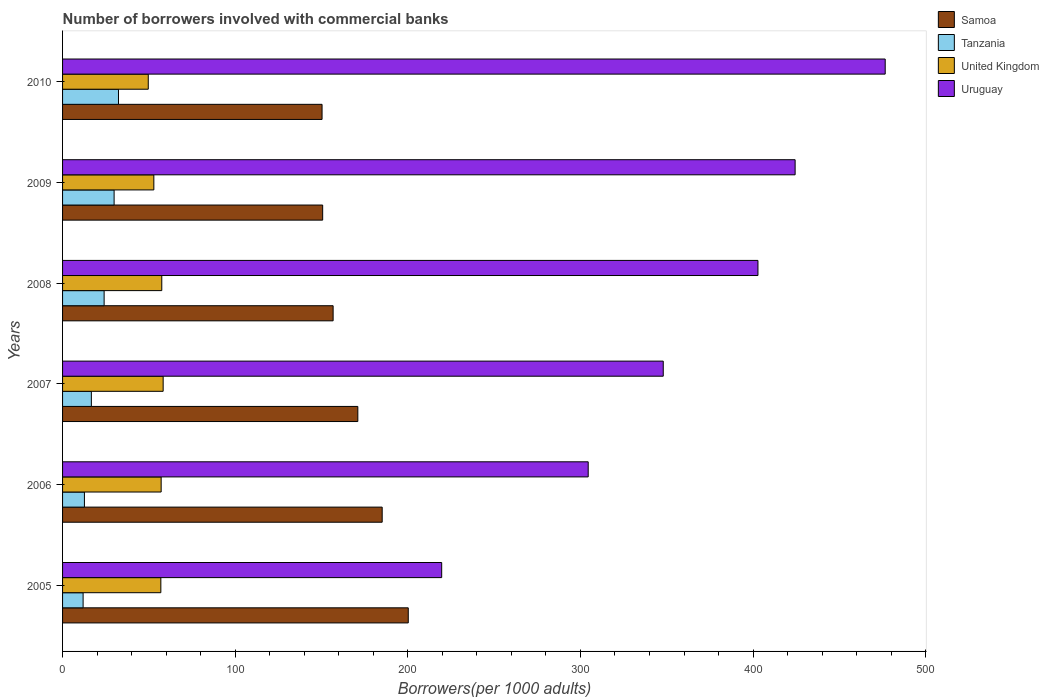How many different coloured bars are there?
Make the answer very short. 4. Are the number of bars per tick equal to the number of legend labels?
Give a very brief answer. Yes. How many bars are there on the 1st tick from the top?
Your answer should be compact. 4. How many bars are there on the 6th tick from the bottom?
Your answer should be compact. 4. In how many cases, is the number of bars for a given year not equal to the number of legend labels?
Make the answer very short. 0. What is the number of borrowers involved with commercial banks in United Kingdom in 2005?
Make the answer very short. 56.93. Across all years, what is the maximum number of borrowers involved with commercial banks in Samoa?
Ensure brevity in your answer.  200.26. Across all years, what is the minimum number of borrowers involved with commercial banks in United Kingdom?
Provide a succinct answer. 49.65. In which year was the number of borrowers involved with commercial banks in Samoa minimum?
Your answer should be very brief. 2010. What is the total number of borrowers involved with commercial banks in United Kingdom in the graph?
Your response must be concise. 332.32. What is the difference between the number of borrowers involved with commercial banks in Uruguay in 2005 and that in 2010?
Your answer should be very brief. -256.93. What is the difference between the number of borrowers involved with commercial banks in Tanzania in 2005 and the number of borrowers involved with commercial banks in United Kingdom in 2008?
Give a very brief answer. -45.57. What is the average number of borrowers involved with commercial banks in Samoa per year?
Provide a succinct answer. 169.03. In the year 2008, what is the difference between the number of borrowers involved with commercial banks in United Kingdom and number of borrowers involved with commercial banks in Uruguay?
Make the answer very short. -345.36. In how many years, is the number of borrowers involved with commercial banks in Tanzania greater than 360 ?
Provide a succinct answer. 0. What is the ratio of the number of borrowers involved with commercial banks in Uruguay in 2007 to that in 2008?
Keep it short and to the point. 0.86. Is the number of borrowers involved with commercial banks in Uruguay in 2006 less than that in 2010?
Your answer should be very brief. Yes. Is the difference between the number of borrowers involved with commercial banks in United Kingdom in 2006 and 2010 greater than the difference between the number of borrowers involved with commercial banks in Uruguay in 2006 and 2010?
Give a very brief answer. Yes. What is the difference between the highest and the second highest number of borrowers involved with commercial banks in Tanzania?
Offer a very short reply. 2.54. What is the difference between the highest and the lowest number of borrowers involved with commercial banks in United Kingdom?
Make the answer very short. 8.62. Is it the case that in every year, the sum of the number of borrowers involved with commercial banks in Tanzania and number of borrowers involved with commercial banks in Samoa is greater than the sum of number of borrowers involved with commercial banks in Uruguay and number of borrowers involved with commercial banks in United Kingdom?
Your answer should be very brief. No. What does the 3rd bar from the top in 2008 represents?
Give a very brief answer. Tanzania. What does the 4th bar from the bottom in 2010 represents?
Offer a very short reply. Uruguay. Is it the case that in every year, the sum of the number of borrowers involved with commercial banks in Uruguay and number of borrowers involved with commercial banks in United Kingdom is greater than the number of borrowers involved with commercial banks in Tanzania?
Offer a terse response. Yes. How many years are there in the graph?
Offer a terse response. 6. Does the graph contain any zero values?
Make the answer very short. No. Does the graph contain grids?
Ensure brevity in your answer.  No. Where does the legend appear in the graph?
Your answer should be compact. Top right. How many legend labels are there?
Give a very brief answer. 4. How are the legend labels stacked?
Ensure brevity in your answer.  Vertical. What is the title of the graph?
Provide a short and direct response. Number of borrowers involved with commercial banks. What is the label or title of the X-axis?
Offer a very short reply. Borrowers(per 1000 adults). What is the label or title of the Y-axis?
Your answer should be very brief. Years. What is the Borrowers(per 1000 adults) of Samoa in 2005?
Provide a succinct answer. 200.26. What is the Borrowers(per 1000 adults) of Tanzania in 2005?
Your answer should be compact. 11.9. What is the Borrowers(per 1000 adults) in United Kingdom in 2005?
Give a very brief answer. 56.93. What is the Borrowers(per 1000 adults) in Uruguay in 2005?
Make the answer very short. 219.62. What is the Borrowers(per 1000 adults) of Samoa in 2006?
Ensure brevity in your answer.  185.16. What is the Borrowers(per 1000 adults) in Tanzania in 2006?
Make the answer very short. 12.66. What is the Borrowers(per 1000 adults) of United Kingdom in 2006?
Your answer should be very brief. 57.12. What is the Borrowers(per 1000 adults) in Uruguay in 2006?
Your answer should be very brief. 304.5. What is the Borrowers(per 1000 adults) in Samoa in 2007?
Provide a succinct answer. 171.04. What is the Borrowers(per 1000 adults) of Tanzania in 2007?
Offer a very short reply. 16.68. What is the Borrowers(per 1000 adults) of United Kingdom in 2007?
Give a very brief answer. 58.27. What is the Borrowers(per 1000 adults) of Uruguay in 2007?
Ensure brevity in your answer.  347.97. What is the Borrowers(per 1000 adults) in Samoa in 2008?
Your answer should be compact. 156.73. What is the Borrowers(per 1000 adults) in Tanzania in 2008?
Your response must be concise. 24.08. What is the Borrowers(per 1000 adults) of United Kingdom in 2008?
Your answer should be compact. 57.47. What is the Borrowers(per 1000 adults) of Uruguay in 2008?
Provide a succinct answer. 402.84. What is the Borrowers(per 1000 adults) of Samoa in 2009?
Provide a succinct answer. 150.68. What is the Borrowers(per 1000 adults) of Tanzania in 2009?
Provide a short and direct response. 29.86. What is the Borrowers(per 1000 adults) of United Kingdom in 2009?
Your answer should be compact. 52.88. What is the Borrowers(per 1000 adults) in Uruguay in 2009?
Keep it short and to the point. 424.36. What is the Borrowers(per 1000 adults) in Samoa in 2010?
Your answer should be compact. 150.32. What is the Borrowers(per 1000 adults) of Tanzania in 2010?
Offer a terse response. 32.39. What is the Borrowers(per 1000 adults) of United Kingdom in 2010?
Offer a terse response. 49.65. What is the Borrowers(per 1000 adults) in Uruguay in 2010?
Provide a short and direct response. 476.55. Across all years, what is the maximum Borrowers(per 1000 adults) of Samoa?
Your response must be concise. 200.26. Across all years, what is the maximum Borrowers(per 1000 adults) in Tanzania?
Offer a terse response. 32.39. Across all years, what is the maximum Borrowers(per 1000 adults) in United Kingdom?
Make the answer very short. 58.27. Across all years, what is the maximum Borrowers(per 1000 adults) in Uruguay?
Your response must be concise. 476.55. Across all years, what is the minimum Borrowers(per 1000 adults) of Samoa?
Your response must be concise. 150.32. Across all years, what is the minimum Borrowers(per 1000 adults) of Tanzania?
Provide a succinct answer. 11.9. Across all years, what is the minimum Borrowers(per 1000 adults) of United Kingdom?
Provide a short and direct response. 49.65. Across all years, what is the minimum Borrowers(per 1000 adults) of Uruguay?
Provide a succinct answer. 219.62. What is the total Borrowers(per 1000 adults) of Samoa in the graph?
Keep it short and to the point. 1014.19. What is the total Borrowers(per 1000 adults) of Tanzania in the graph?
Keep it short and to the point. 127.56. What is the total Borrowers(per 1000 adults) in United Kingdom in the graph?
Your response must be concise. 332.32. What is the total Borrowers(per 1000 adults) in Uruguay in the graph?
Keep it short and to the point. 2175.85. What is the difference between the Borrowers(per 1000 adults) of Samoa in 2005 and that in 2006?
Make the answer very short. 15.11. What is the difference between the Borrowers(per 1000 adults) of Tanzania in 2005 and that in 2006?
Ensure brevity in your answer.  -0.76. What is the difference between the Borrowers(per 1000 adults) of United Kingdom in 2005 and that in 2006?
Offer a terse response. -0.19. What is the difference between the Borrowers(per 1000 adults) in Uruguay in 2005 and that in 2006?
Provide a short and direct response. -84.88. What is the difference between the Borrowers(per 1000 adults) in Samoa in 2005 and that in 2007?
Keep it short and to the point. 29.22. What is the difference between the Borrowers(per 1000 adults) in Tanzania in 2005 and that in 2007?
Offer a terse response. -4.78. What is the difference between the Borrowers(per 1000 adults) in United Kingdom in 2005 and that in 2007?
Provide a short and direct response. -1.34. What is the difference between the Borrowers(per 1000 adults) of Uruguay in 2005 and that in 2007?
Make the answer very short. -128.35. What is the difference between the Borrowers(per 1000 adults) of Samoa in 2005 and that in 2008?
Give a very brief answer. 43.53. What is the difference between the Borrowers(per 1000 adults) of Tanzania in 2005 and that in 2008?
Offer a terse response. -12.17. What is the difference between the Borrowers(per 1000 adults) in United Kingdom in 2005 and that in 2008?
Your response must be concise. -0.54. What is the difference between the Borrowers(per 1000 adults) in Uruguay in 2005 and that in 2008?
Ensure brevity in your answer.  -183.21. What is the difference between the Borrowers(per 1000 adults) of Samoa in 2005 and that in 2009?
Give a very brief answer. 49.59. What is the difference between the Borrowers(per 1000 adults) in Tanzania in 2005 and that in 2009?
Keep it short and to the point. -17.95. What is the difference between the Borrowers(per 1000 adults) in United Kingdom in 2005 and that in 2009?
Your answer should be compact. 4.05. What is the difference between the Borrowers(per 1000 adults) in Uruguay in 2005 and that in 2009?
Provide a short and direct response. -204.74. What is the difference between the Borrowers(per 1000 adults) of Samoa in 2005 and that in 2010?
Your answer should be compact. 49.94. What is the difference between the Borrowers(per 1000 adults) of Tanzania in 2005 and that in 2010?
Give a very brief answer. -20.49. What is the difference between the Borrowers(per 1000 adults) in United Kingdom in 2005 and that in 2010?
Offer a terse response. 7.28. What is the difference between the Borrowers(per 1000 adults) of Uruguay in 2005 and that in 2010?
Give a very brief answer. -256.93. What is the difference between the Borrowers(per 1000 adults) of Samoa in 2006 and that in 2007?
Your answer should be very brief. 14.11. What is the difference between the Borrowers(per 1000 adults) in Tanzania in 2006 and that in 2007?
Your answer should be very brief. -4.02. What is the difference between the Borrowers(per 1000 adults) in United Kingdom in 2006 and that in 2007?
Your answer should be compact. -1.15. What is the difference between the Borrowers(per 1000 adults) in Uruguay in 2006 and that in 2007?
Make the answer very short. -43.47. What is the difference between the Borrowers(per 1000 adults) in Samoa in 2006 and that in 2008?
Give a very brief answer. 28.42. What is the difference between the Borrowers(per 1000 adults) in Tanzania in 2006 and that in 2008?
Your response must be concise. -11.42. What is the difference between the Borrowers(per 1000 adults) in United Kingdom in 2006 and that in 2008?
Offer a terse response. -0.36. What is the difference between the Borrowers(per 1000 adults) in Uruguay in 2006 and that in 2008?
Your answer should be compact. -98.33. What is the difference between the Borrowers(per 1000 adults) in Samoa in 2006 and that in 2009?
Ensure brevity in your answer.  34.48. What is the difference between the Borrowers(per 1000 adults) of Tanzania in 2006 and that in 2009?
Your answer should be very brief. -17.2. What is the difference between the Borrowers(per 1000 adults) of United Kingdom in 2006 and that in 2009?
Make the answer very short. 4.24. What is the difference between the Borrowers(per 1000 adults) in Uruguay in 2006 and that in 2009?
Your answer should be very brief. -119.86. What is the difference between the Borrowers(per 1000 adults) in Samoa in 2006 and that in 2010?
Offer a terse response. 34.83. What is the difference between the Borrowers(per 1000 adults) of Tanzania in 2006 and that in 2010?
Provide a short and direct response. -19.73. What is the difference between the Borrowers(per 1000 adults) in United Kingdom in 2006 and that in 2010?
Your answer should be very brief. 7.47. What is the difference between the Borrowers(per 1000 adults) in Uruguay in 2006 and that in 2010?
Give a very brief answer. -172.05. What is the difference between the Borrowers(per 1000 adults) in Samoa in 2007 and that in 2008?
Ensure brevity in your answer.  14.31. What is the difference between the Borrowers(per 1000 adults) of Tanzania in 2007 and that in 2008?
Provide a short and direct response. -7.4. What is the difference between the Borrowers(per 1000 adults) in United Kingdom in 2007 and that in 2008?
Ensure brevity in your answer.  0.8. What is the difference between the Borrowers(per 1000 adults) of Uruguay in 2007 and that in 2008?
Make the answer very short. -54.86. What is the difference between the Borrowers(per 1000 adults) in Samoa in 2007 and that in 2009?
Offer a terse response. 20.37. What is the difference between the Borrowers(per 1000 adults) in Tanzania in 2007 and that in 2009?
Your answer should be compact. -13.18. What is the difference between the Borrowers(per 1000 adults) of United Kingdom in 2007 and that in 2009?
Ensure brevity in your answer.  5.39. What is the difference between the Borrowers(per 1000 adults) of Uruguay in 2007 and that in 2009?
Ensure brevity in your answer.  -76.39. What is the difference between the Borrowers(per 1000 adults) of Samoa in 2007 and that in 2010?
Ensure brevity in your answer.  20.72. What is the difference between the Borrowers(per 1000 adults) of Tanzania in 2007 and that in 2010?
Provide a short and direct response. -15.71. What is the difference between the Borrowers(per 1000 adults) of United Kingdom in 2007 and that in 2010?
Provide a succinct answer. 8.62. What is the difference between the Borrowers(per 1000 adults) in Uruguay in 2007 and that in 2010?
Provide a short and direct response. -128.58. What is the difference between the Borrowers(per 1000 adults) in Samoa in 2008 and that in 2009?
Offer a very short reply. 6.06. What is the difference between the Borrowers(per 1000 adults) in Tanzania in 2008 and that in 2009?
Your answer should be very brief. -5.78. What is the difference between the Borrowers(per 1000 adults) in United Kingdom in 2008 and that in 2009?
Your answer should be very brief. 4.59. What is the difference between the Borrowers(per 1000 adults) in Uruguay in 2008 and that in 2009?
Keep it short and to the point. -21.53. What is the difference between the Borrowers(per 1000 adults) of Samoa in 2008 and that in 2010?
Your answer should be compact. 6.41. What is the difference between the Borrowers(per 1000 adults) in Tanzania in 2008 and that in 2010?
Give a very brief answer. -8.32. What is the difference between the Borrowers(per 1000 adults) of United Kingdom in 2008 and that in 2010?
Ensure brevity in your answer.  7.83. What is the difference between the Borrowers(per 1000 adults) in Uruguay in 2008 and that in 2010?
Offer a very short reply. -73.71. What is the difference between the Borrowers(per 1000 adults) in Samoa in 2009 and that in 2010?
Keep it short and to the point. 0.35. What is the difference between the Borrowers(per 1000 adults) of Tanzania in 2009 and that in 2010?
Provide a succinct answer. -2.54. What is the difference between the Borrowers(per 1000 adults) of United Kingdom in 2009 and that in 2010?
Offer a very short reply. 3.23. What is the difference between the Borrowers(per 1000 adults) of Uruguay in 2009 and that in 2010?
Your response must be concise. -52.19. What is the difference between the Borrowers(per 1000 adults) of Samoa in 2005 and the Borrowers(per 1000 adults) of Tanzania in 2006?
Ensure brevity in your answer.  187.61. What is the difference between the Borrowers(per 1000 adults) in Samoa in 2005 and the Borrowers(per 1000 adults) in United Kingdom in 2006?
Ensure brevity in your answer.  143.15. What is the difference between the Borrowers(per 1000 adults) of Samoa in 2005 and the Borrowers(per 1000 adults) of Uruguay in 2006?
Ensure brevity in your answer.  -104.24. What is the difference between the Borrowers(per 1000 adults) in Tanzania in 2005 and the Borrowers(per 1000 adults) in United Kingdom in 2006?
Make the answer very short. -45.22. What is the difference between the Borrowers(per 1000 adults) of Tanzania in 2005 and the Borrowers(per 1000 adults) of Uruguay in 2006?
Ensure brevity in your answer.  -292.6. What is the difference between the Borrowers(per 1000 adults) of United Kingdom in 2005 and the Borrowers(per 1000 adults) of Uruguay in 2006?
Offer a terse response. -247.57. What is the difference between the Borrowers(per 1000 adults) of Samoa in 2005 and the Borrowers(per 1000 adults) of Tanzania in 2007?
Your answer should be very brief. 183.58. What is the difference between the Borrowers(per 1000 adults) of Samoa in 2005 and the Borrowers(per 1000 adults) of United Kingdom in 2007?
Keep it short and to the point. 141.99. What is the difference between the Borrowers(per 1000 adults) in Samoa in 2005 and the Borrowers(per 1000 adults) in Uruguay in 2007?
Ensure brevity in your answer.  -147.71. What is the difference between the Borrowers(per 1000 adults) of Tanzania in 2005 and the Borrowers(per 1000 adults) of United Kingdom in 2007?
Offer a very short reply. -46.37. What is the difference between the Borrowers(per 1000 adults) of Tanzania in 2005 and the Borrowers(per 1000 adults) of Uruguay in 2007?
Provide a short and direct response. -336.07. What is the difference between the Borrowers(per 1000 adults) of United Kingdom in 2005 and the Borrowers(per 1000 adults) of Uruguay in 2007?
Offer a terse response. -291.04. What is the difference between the Borrowers(per 1000 adults) of Samoa in 2005 and the Borrowers(per 1000 adults) of Tanzania in 2008?
Provide a short and direct response. 176.19. What is the difference between the Borrowers(per 1000 adults) in Samoa in 2005 and the Borrowers(per 1000 adults) in United Kingdom in 2008?
Offer a very short reply. 142.79. What is the difference between the Borrowers(per 1000 adults) of Samoa in 2005 and the Borrowers(per 1000 adults) of Uruguay in 2008?
Provide a succinct answer. -202.57. What is the difference between the Borrowers(per 1000 adults) in Tanzania in 2005 and the Borrowers(per 1000 adults) in United Kingdom in 2008?
Your answer should be compact. -45.57. What is the difference between the Borrowers(per 1000 adults) of Tanzania in 2005 and the Borrowers(per 1000 adults) of Uruguay in 2008?
Offer a very short reply. -390.94. What is the difference between the Borrowers(per 1000 adults) in United Kingdom in 2005 and the Borrowers(per 1000 adults) in Uruguay in 2008?
Offer a very short reply. -345.91. What is the difference between the Borrowers(per 1000 adults) in Samoa in 2005 and the Borrowers(per 1000 adults) in Tanzania in 2009?
Your response must be concise. 170.41. What is the difference between the Borrowers(per 1000 adults) in Samoa in 2005 and the Borrowers(per 1000 adults) in United Kingdom in 2009?
Ensure brevity in your answer.  147.38. What is the difference between the Borrowers(per 1000 adults) of Samoa in 2005 and the Borrowers(per 1000 adults) of Uruguay in 2009?
Provide a succinct answer. -224.1. What is the difference between the Borrowers(per 1000 adults) in Tanzania in 2005 and the Borrowers(per 1000 adults) in United Kingdom in 2009?
Make the answer very short. -40.98. What is the difference between the Borrowers(per 1000 adults) of Tanzania in 2005 and the Borrowers(per 1000 adults) of Uruguay in 2009?
Provide a short and direct response. -412.46. What is the difference between the Borrowers(per 1000 adults) in United Kingdom in 2005 and the Borrowers(per 1000 adults) in Uruguay in 2009?
Your answer should be compact. -367.43. What is the difference between the Borrowers(per 1000 adults) in Samoa in 2005 and the Borrowers(per 1000 adults) in Tanzania in 2010?
Provide a short and direct response. 167.87. What is the difference between the Borrowers(per 1000 adults) in Samoa in 2005 and the Borrowers(per 1000 adults) in United Kingdom in 2010?
Provide a short and direct response. 150.62. What is the difference between the Borrowers(per 1000 adults) of Samoa in 2005 and the Borrowers(per 1000 adults) of Uruguay in 2010?
Your answer should be very brief. -276.29. What is the difference between the Borrowers(per 1000 adults) in Tanzania in 2005 and the Borrowers(per 1000 adults) in United Kingdom in 2010?
Your response must be concise. -37.75. What is the difference between the Borrowers(per 1000 adults) of Tanzania in 2005 and the Borrowers(per 1000 adults) of Uruguay in 2010?
Your answer should be compact. -464.65. What is the difference between the Borrowers(per 1000 adults) in United Kingdom in 2005 and the Borrowers(per 1000 adults) in Uruguay in 2010?
Keep it short and to the point. -419.62. What is the difference between the Borrowers(per 1000 adults) of Samoa in 2006 and the Borrowers(per 1000 adults) of Tanzania in 2007?
Your response must be concise. 168.47. What is the difference between the Borrowers(per 1000 adults) in Samoa in 2006 and the Borrowers(per 1000 adults) in United Kingdom in 2007?
Your answer should be compact. 126.88. What is the difference between the Borrowers(per 1000 adults) in Samoa in 2006 and the Borrowers(per 1000 adults) in Uruguay in 2007?
Your response must be concise. -162.82. What is the difference between the Borrowers(per 1000 adults) of Tanzania in 2006 and the Borrowers(per 1000 adults) of United Kingdom in 2007?
Provide a short and direct response. -45.61. What is the difference between the Borrowers(per 1000 adults) of Tanzania in 2006 and the Borrowers(per 1000 adults) of Uruguay in 2007?
Give a very brief answer. -335.32. What is the difference between the Borrowers(per 1000 adults) in United Kingdom in 2006 and the Borrowers(per 1000 adults) in Uruguay in 2007?
Provide a succinct answer. -290.86. What is the difference between the Borrowers(per 1000 adults) in Samoa in 2006 and the Borrowers(per 1000 adults) in Tanzania in 2008?
Your answer should be very brief. 161.08. What is the difference between the Borrowers(per 1000 adults) of Samoa in 2006 and the Borrowers(per 1000 adults) of United Kingdom in 2008?
Offer a terse response. 127.68. What is the difference between the Borrowers(per 1000 adults) of Samoa in 2006 and the Borrowers(per 1000 adults) of Uruguay in 2008?
Offer a terse response. -217.68. What is the difference between the Borrowers(per 1000 adults) in Tanzania in 2006 and the Borrowers(per 1000 adults) in United Kingdom in 2008?
Your response must be concise. -44.82. What is the difference between the Borrowers(per 1000 adults) in Tanzania in 2006 and the Borrowers(per 1000 adults) in Uruguay in 2008?
Your response must be concise. -390.18. What is the difference between the Borrowers(per 1000 adults) in United Kingdom in 2006 and the Borrowers(per 1000 adults) in Uruguay in 2008?
Provide a succinct answer. -345.72. What is the difference between the Borrowers(per 1000 adults) in Samoa in 2006 and the Borrowers(per 1000 adults) in Tanzania in 2009?
Make the answer very short. 155.3. What is the difference between the Borrowers(per 1000 adults) of Samoa in 2006 and the Borrowers(per 1000 adults) of United Kingdom in 2009?
Provide a succinct answer. 132.27. What is the difference between the Borrowers(per 1000 adults) of Samoa in 2006 and the Borrowers(per 1000 adults) of Uruguay in 2009?
Give a very brief answer. -239.21. What is the difference between the Borrowers(per 1000 adults) in Tanzania in 2006 and the Borrowers(per 1000 adults) in United Kingdom in 2009?
Give a very brief answer. -40.22. What is the difference between the Borrowers(per 1000 adults) in Tanzania in 2006 and the Borrowers(per 1000 adults) in Uruguay in 2009?
Provide a short and direct response. -411.71. What is the difference between the Borrowers(per 1000 adults) in United Kingdom in 2006 and the Borrowers(per 1000 adults) in Uruguay in 2009?
Give a very brief answer. -367.25. What is the difference between the Borrowers(per 1000 adults) in Samoa in 2006 and the Borrowers(per 1000 adults) in Tanzania in 2010?
Ensure brevity in your answer.  152.76. What is the difference between the Borrowers(per 1000 adults) of Samoa in 2006 and the Borrowers(per 1000 adults) of United Kingdom in 2010?
Offer a terse response. 135.51. What is the difference between the Borrowers(per 1000 adults) in Samoa in 2006 and the Borrowers(per 1000 adults) in Uruguay in 2010?
Your response must be concise. -291.4. What is the difference between the Borrowers(per 1000 adults) in Tanzania in 2006 and the Borrowers(per 1000 adults) in United Kingdom in 2010?
Offer a terse response. -36.99. What is the difference between the Borrowers(per 1000 adults) in Tanzania in 2006 and the Borrowers(per 1000 adults) in Uruguay in 2010?
Offer a very short reply. -463.89. What is the difference between the Borrowers(per 1000 adults) in United Kingdom in 2006 and the Borrowers(per 1000 adults) in Uruguay in 2010?
Offer a very short reply. -419.43. What is the difference between the Borrowers(per 1000 adults) in Samoa in 2007 and the Borrowers(per 1000 adults) in Tanzania in 2008?
Your answer should be very brief. 146.97. What is the difference between the Borrowers(per 1000 adults) of Samoa in 2007 and the Borrowers(per 1000 adults) of United Kingdom in 2008?
Provide a succinct answer. 113.57. What is the difference between the Borrowers(per 1000 adults) in Samoa in 2007 and the Borrowers(per 1000 adults) in Uruguay in 2008?
Give a very brief answer. -231.79. What is the difference between the Borrowers(per 1000 adults) of Tanzania in 2007 and the Borrowers(per 1000 adults) of United Kingdom in 2008?
Make the answer very short. -40.79. What is the difference between the Borrowers(per 1000 adults) in Tanzania in 2007 and the Borrowers(per 1000 adults) in Uruguay in 2008?
Your answer should be very brief. -386.16. What is the difference between the Borrowers(per 1000 adults) in United Kingdom in 2007 and the Borrowers(per 1000 adults) in Uruguay in 2008?
Keep it short and to the point. -344.57. What is the difference between the Borrowers(per 1000 adults) of Samoa in 2007 and the Borrowers(per 1000 adults) of Tanzania in 2009?
Your answer should be very brief. 141.19. What is the difference between the Borrowers(per 1000 adults) in Samoa in 2007 and the Borrowers(per 1000 adults) in United Kingdom in 2009?
Ensure brevity in your answer.  118.16. What is the difference between the Borrowers(per 1000 adults) in Samoa in 2007 and the Borrowers(per 1000 adults) in Uruguay in 2009?
Ensure brevity in your answer.  -253.32. What is the difference between the Borrowers(per 1000 adults) of Tanzania in 2007 and the Borrowers(per 1000 adults) of United Kingdom in 2009?
Your answer should be very brief. -36.2. What is the difference between the Borrowers(per 1000 adults) in Tanzania in 2007 and the Borrowers(per 1000 adults) in Uruguay in 2009?
Offer a terse response. -407.68. What is the difference between the Borrowers(per 1000 adults) in United Kingdom in 2007 and the Borrowers(per 1000 adults) in Uruguay in 2009?
Your response must be concise. -366.09. What is the difference between the Borrowers(per 1000 adults) of Samoa in 2007 and the Borrowers(per 1000 adults) of Tanzania in 2010?
Provide a succinct answer. 138.65. What is the difference between the Borrowers(per 1000 adults) in Samoa in 2007 and the Borrowers(per 1000 adults) in United Kingdom in 2010?
Provide a succinct answer. 121.4. What is the difference between the Borrowers(per 1000 adults) of Samoa in 2007 and the Borrowers(per 1000 adults) of Uruguay in 2010?
Offer a very short reply. -305.51. What is the difference between the Borrowers(per 1000 adults) in Tanzania in 2007 and the Borrowers(per 1000 adults) in United Kingdom in 2010?
Your answer should be compact. -32.97. What is the difference between the Borrowers(per 1000 adults) of Tanzania in 2007 and the Borrowers(per 1000 adults) of Uruguay in 2010?
Ensure brevity in your answer.  -459.87. What is the difference between the Borrowers(per 1000 adults) in United Kingdom in 2007 and the Borrowers(per 1000 adults) in Uruguay in 2010?
Ensure brevity in your answer.  -418.28. What is the difference between the Borrowers(per 1000 adults) of Samoa in 2008 and the Borrowers(per 1000 adults) of Tanzania in 2009?
Provide a succinct answer. 126.88. What is the difference between the Borrowers(per 1000 adults) of Samoa in 2008 and the Borrowers(per 1000 adults) of United Kingdom in 2009?
Your answer should be very brief. 103.85. What is the difference between the Borrowers(per 1000 adults) in Samoa in 2008 and the Borrowers(per 1000 adults) in Uruguay in 2009?
Ensure brevity in your answer.  -267.63. What is the difference between the Borrowers(per 1000 adults) in Tanzania in 2008 and the Borrowers(per 1000 adults) in United Kingdom in 2009?
Make the answer very short. -28.81. What is the difference between the Borrowers(per 1000 adults) in Tanzania in 2008 and the Borrowers(per 1000 adults) in Uruguay in 2009?
Provide a short and direct response. -400.29. What is the difference between the Borrowers(per 1000 adults) of United Kingdom in 2008 and the Borrowers(per 1000 adults) of Uruguay in 2009?
Provide a succinct answer. -366.89. What is the difference between the Borrowers(per 1000 adults) in Samoa in 2008 and the Borrowers(per 1000 adults) in Tanzania in 2010?
Your answer should be very brief. 124.34. What is the difference between the Borrowers(per 1000 adults) in Samoa in 2008 and the Borrowers(per 1000 adults) in United Kingdom in 2010?
Your response must be concise. 107.09. What is the difference between the Borrowers(per 1000 adults) in Samoa in 2008 and the Borrowers(per 1000 adults) in Uruguay in 2010?
Give a very brief answer. -319.82. What is the difference between the Borrowers(per 1000 adults) in Tanzania in 2008 and the Borrowers(per 1000 adults) in United Kingdom in 2010?
Offer a terse response. -25.57. What is the difference between the Borrowers(per 1000 adults) in Tanzania in 2008 and the Borrowers(per 1000 adults) in Uruguay in 2010?
Ensure brevity in your answer.  -452.48. What is the difference between the Borrowers(per 1000 adults) of United Kingdom in 2008 and the Borrowers(per 1000 adults) of Uruguay in 2010?
Your response must be concise. -419.08. What is the difference between the Borrowers(per 1000 adults) in Samoa in 2009 and the Borrowers(per 1000 adults) in Tanzania in 2010?
Keep it short and to the point. 118.28. What is the difference between the Borrowers(per 1000 adults) of Samoa in 2009 and the Borrowers(per 1000 adults) of United Kingdom in 2010?
Your response must be concise. 101.03. What is the difference between the Borrowers(per 1000 adults) in Samoa in 2009 and the Borrowers(per 1000 adults) in Uruguay in 2010?
Your response must be concise. -325.88. What is the difference between the Borrowers(per 1000 adults) of Tanzania in 2009 and the Borrowers(per 1000 adults) of United Kingdom in 2010?
Your response must be concise. -19.79. What is the difference between the Borrowers(per 1000 adults) in Tanzania in 2009 and the Borrowers(per 1000 adults) in Uruguay in 2010?
Make the answer very short. -446.7. What is the difference between the Borrowers(per 1000 adults) of United Kingdom in 2009 and the Borrowers(per 1000 adults) of Uruguay in 2010?
Offer a terse response. -423.67. What is the average Borrowers(per 1000 adults) in Samoa per year?
Ensure brevity in your answer.  169.03. What is the average Borrowers(per 1000 adults) of Tanzania per year?
Provide a succinct answer. 21.26. What is the average Borrowers(per 1000 adults) of United Kingdom per year?
Offer a terse response. 55.39. What is the average Borrowers(per 1000 adults) of Uruguay per year?
Offer a terse response. 362.64. In the year 2005, what is the difference between the Borrowers(per 1000 adults) of Samoa and Borrowers(per 1000 adults) of Tanzania?
Provide a short and direct response. 188.36. In the year 2005, what is the difference between the Borrowers(per 1000 adults) in Samoa and Borrowers(per 1000 adults) in United Kingdom?
Make the answer very short. 143.33. In the year 2005, what is the difference between the Borrowers(per 1000 adults) in Samoa and Borrowers(per 1000 adults) in Uruguay?
Your answer should be very brief. -19.36. In the year 2005, what is the difference between the Borrowers(per 1000 adults) in Tanzania and Borrowers(per 1000 adults) in United Kingdom?
Give a very brief answer. -45.03. In the year 2005, what is the difference between the Borrowers(per 1000 adults) of Tanzania and Borrowers(per 1000 adults) of Uruguay?
Provide a short and direct response. -207.72. In the year 2005, what is the difference between the Borrowers(per 1000 adults) in United Kingdom and Borrowers(per 1000 adults) in Uruguay?
Keep it short and to the point. -162.69. In the year 2006, what is the difference between the Borrowers(per 1000 adults) of Samoa and Borrowers(per 1000 adults) of Tanzania?
Make the answer very short. 172.5. In the year 2006, what is the difference between the Borrowers(per 1000 adults) of Samoa and Borrowers(per 1000 adults) of United Kingdom?
Offer a very short reply. 128.04. In the year 2006, what is the difference between the Borrowers(per 1000 adults) in Samoa and Borrowers(per 1000 adults) in Uruguay?
Provide a short and direct response. -119.35. In the year 2006, what is the difference between the Borrowers(per 1000 adults) of Tanzania and Borrowers(per 1000 adults) of United Kingdom?
Your answer should be very brief. -44.46. In the year 2006, what is the difference between the Borrowers(per 1000 adults) of Tanzania and Borrowers(per 1000 adults) of Uruguay?
Ensure brevity in your answer.  -291.85. In the year 2006, what is the difference between the Borrowers(per 1000 adults) in United Kingdom and Borrowers(per 1000 adults) in Uruguay?
Your response must be concise. -247.39. In the year 2007, what is the difference between the Borrowers(per 1000 adults) of Samoa and Borrowers(per 1000 adults) of Tanzania?
Give a very brief answer. 154.36. In the year 2007, what is the difference between the Borrowers(per 1000 adults) of Samoa and Borrowers(per 1000 adults) of United Kingdom?
Keep it short and to the point. 112.77. In the year 2007, what is the difference between the Borrowers(per 1000 adults) in Samoa and Borrowers(per 1000 adults) in Uruguay?
Offer a terse response. -176.93. In the year 2007, what is the difference between the Borrowers(per 1000 adults) in Tanzania and Borrowers(per 1000 adults) in United Kingdom?
Ensure brevity in your answer.  -41.59. In the year 2007, what is the difference between the Borrowers(per 1000 adults) in Tanzania and Borrowers(per 1000 adults) in Uruguay?
Keep it short and to the point. -331.29. In the year 2007, what is the difference between the Borrowers(per 1000 adults) in United Kingdom and Borrowers(per 1000 adults) in Uruguay?
Your response must be concise. -289.7. In the year 2008, what is the difference between the Borrowers(per 1000 adults) in Samoa and Borrowers(per 1000 adults) in Tanzania?
Provide a succinct answer. 132.66. In the year 2008, what is the difference between the Borrowers(per 1000 adults) of Samoa and Borrowers(per 1000 adults) of United Kingdom?
Ensure brevity in your answer.  99.26. In the year 2008, what is the difference between the Borrowers(per 1000 adults) in Samoa and Borrowers(per 1000 adults) in Uruguay?
Your answer should be very brief. -246.1. In the year 2008, what is the difference between the Borrowers(per 1000 adults) of Tanzania and Borrowers(per 1000 adults) of United Kingdom?
Your answer should be compact. -33.4. In the year 2008, what is the difference between the Borrowers(per 1000 adults) in Tanzania and Borrowers(per 1000 adults) in Uruguay?
Make the answer very short. -378.76. In the year 2008, what is the difference between the Borrowers(per 1000 adults) of United Kingdom and Borrowers(per 1000 adults) of Uruguay?
Keep it short and to the point. -345.36. In the year 2009, what is the difference between the Borrowers(per 1000 adults) of Samoa and Borrowers(per 1000 adults) of Tanzania?
Provide a short and direct response. 120.82. In the year 2009, what is the difference between the Borrowers(per 1000 adults) of Samoa and Borrowers(per 1000 adults) of United Kingdom?
Your response must be concise. 97.79. In the year 2009, what is the difference between the Borrowers(per 1000 adults) of Samoa and Borrowers(per 1000 adults) of Uruguay?
Provide a short and direct response. -273.69. In the year 2009, what is the difference between the Borrowers(per 1000 adults) of Tanzania and Borrowers(per 1000 adults) of United Kingdom?
Offer a very short reply. -23.03. In the year 2009, what is the difference between the Borrowers(per 1000 adults) in Tanzania and Borrowers(per 1000 adults) in Uruguay?
Make the answer very short. -394.51. In the year 2009, what is the difference between the Borrowers(per 1000 adults) in United Kingdom and Borrowers(per 1000 adults) in Uruguay?
Offer a terse response. -371.48. In the year 2010, what is the difference between the Borrowers(per 1000 adults) of Samoa and Borrowers(per 1000 adults) of Tanzania?
Your response must be concise. 117.93. In the year 2010, what is the difference between the Borrowers(per 1000 adults) in Samoa and Borrowers(per 1000 adults) in United Kingdom?
Provide a succinct answer. 100.68. In the year 2010, what is the difference between the Borrowers(per 1000 adults) in Samoa and Borrowers(per 1000 adults) in Uruguay?
Ensure brevity in your answer.  -326.23. In the year 2010, what is the difference between the Borrowers(per 1000 adults) of Tanzania and Borrowers(per 1000 adults) of United Kingdom?
Offer a terse response. -17.26. In the year 2010, what is the difference between the Borrowers(per 1000 adults) of Tanzania and Borrowers(per 1000 adults) of Uruguay?
Provide a short and direct response. -444.16. In the year 2010, what is the difference between the Borrowers(per 1000 adults) in United Kingdom and Borrowers(per 1000 adults) in Uruguay?
Your response must be concise. -426.9. What is the ratio of the Borrowers(per 1000 adults) of Samoa in 2005 to that in 2006?
Provide a succinct answer. 1.08. What is the ratio of the Borrowers(per 1000 adults) of Tanzania in 2005 to that in 2006?
Offer a terse response. 0.94. What is the ratio of the Borrowers(per 1000 adults) in Uruguay in 2005 to that in 2006?
Give a very brief answer. 0.72. What is the ratio of the Borrowers(per 1000 adults) in Samoa in 2005 to that in 2007?
Make the answer very short. 1.17. What is the ratio of the Borrowers(per 1000 adults) in Tanzania in 2005 to that in 2007?
Keep it short and to the point. 0.71. What is the ratio of the Borrowers(per 1000 adults) of Uruguay in 2005 to that in 2007?
Your answer should be compact. 0.63. What is the ratio of the Borrowers(per 1000 adults) in Samoa in 2005 to that in 2008?
Keep it short and to the point. 1.28. What is the ratio of the Borrowers(per 1000 adults) of Tanzania in 2005 to that in 2008?
Offer a very short reply. 0.49. What is the ratio of the Borrowers(per 1000 adults) in Uruguay in 2005 to that in 2008?
Provide a succinct answer. 0.55. What is the ratio of the Borrowers(per 1000 adults) of Samoa in 2005 to that in 2009?
Your answer should be compact. 1.33. What is the ratio of the Borrowers(per 1000 adults) in Tanzania in 2005 to that in 2009?
Ensure brevity in your answer.  0.4. What is the ratio of the Borrowers(per 1000 adults) in United Kingdom in 2005 to that in 2009?
Your answer should be very brief. 1.08. What is the ratio of the Borrowers(per 1000 adults) in Uruguay in 2005 to that in 2009?
Provide a succinct answer. 0.52. What is the ratio of the Borrowers(per 1000 adults) of Samoa in 2005 to that in 2010?
Make the answer very short. 1.33. What is the ratio of the Borrowers(per 1000 adults) of Tanzania in 2005 to that in 2010?
Provide a short and direct response. 0.37. What is the ratio of the Borrowers(per 1000 adults) of United Kingdom in 2005 to that in 2010?
Offer a very short reply. 1.15. What is the ratio of the Borrowers(per 1000 adults) of Uruguay in 2005 to that in 2010?
Your answer should be very brief. 0.46. What is the ratio of the Borrowers(per 1000 adults) of Samoa in 2006 to that in 2007?
Keep it short and to the point. 1.08. What is the ratio of the Borrowers(per 1000 adults) of Tanzania in 2006 to that in 2007?
Provide a short and direct response. 0.76. What is the ratio of the Borrowers(per 1000 adults) in United Kingdom in 2006 to that in 2007?
Your response must be concise. 0.98. What is the ratio of the Borrowers(per 1000 adults) in Uruguay in 2006 to that in 2007?
Your answer should be compact. 0.88. What is the ratio of the Borrowers(per 1000 adults) of Samoa in 2006 to that in 2008?
Keep it short and to the point. 1.18. What is the ratio of the Borrowers(per 1000 adults) in Tanzania in 2006 to that in 2008?
Give a very brief answer. 0.53. What is the ratio of the Borrowers(per 1000 adults) of United Kingdom in 2006 to that in 2008?
Keep it short and to the point. 0.99. What is the ratio of the Borrowers(per 1000 adults) in Uruguay in 2006 to that in 2008?
Offer a terse response. 0.76. What is the ratio of the Borrowers(per 1000 adults) in Samoa in 2006 to that in 2009?
Provide a succinct answer. 1.23. What is the ratio of the Borrowers(per 1000 adults) in Tanzania in 2006 to that in 2009?
Provide a succinct answer. 0.42. What is the ratio of the Borrowers(per 1000 adults) in United Kingdom in 2006 to that in 2009?
Offer a very short reply. 1.08. What is the ratio of the Borrowers(per 1000 adults) of Uruguay in 2006 to that in 2009?
Your answer should be compact. 0.72. What is the ratio of the Borrowers(per 1000 adults) of Samoa in 2006 to that in 2010?
Keep it short and to the point. 1.23. What is the ratio of the Borrowers(per 1000 adults) in Tanzania in 2006 to that in 2010?
Your response must be concise. 0.39. What is the ratio of the Borrowers(per 1000 adults) in United Kingdom in 2006 to that in 2010?
Ensure brevity in your answer.  1.15. What is the ratio of the Borrowers(per 1000 adults) in Uruguay in 2006 to that in 2010?
Your answer should be compact. 0.64. What is the ratio of the Borrowers(per 1000 adults) of Samoa in 2007 to that in 2008?
Ensure brevity in your answer.  1.09. What is the ratio of the Borrowers(per 1000 adults) in Tanzania in 2007 to that in 2008?
Provide a succinct answer. 0.69. What is the ratio of the Borrowers(per 1000 adults) in United Kingdom in 2007 to that in 2008?
Ensure brevity in your answer.  1.01. What is the ratio of the Borrowers(per 1000 adults) in Uruguay in 2007 to that in 2008?
Ensure brevity in your answer.  0.86. What is the ratio of the Borrowers(per 1000 adults) of Samoa in 2007 to that in 2009?
Your answer should be very brief. 1.14. What is the ratio of the Borrowers(per 1000 adults) in Tanzania in 2007 to that in 2009?
Provide a short and direct response. 0.56. What is the ratio of the Borrowers(per 1000 adults) in United Kingdom in 2007 to that in 2009?
Provide a short and direct response. 1.1. What is the ratio of the Borrowers(per 1000 adults) of Uruguay in 2007 to that in 2009?
Keep it short and to the point. 0.82. What is the ratio of the Borrowers(per 1000 adults) in Samoa in 2007 to that in 2010?
Provide a short and direct response. 1.14. What is the ratio of the Borrowers(per 1000 adults) in Tanzania in 2007 to that in 2010?
Your response must be concise. 0.52. What is the ratio of the Borrowers(per 1000 adults) in United Kingdom in 2007 to that in 2010?
Your answer should be compact. 1.17. What is the ratio of the Borrowers(per 1000 adults) in Uruguay in 2007 to that in 2010?
Your answer should be compact. 0.73. What is the ratio of the Borrowers(per 1000 adults) in Samoa in 2008 to that in 2009?
Your answer should be compact. 1.04. What is the ratio of the Borrowers(per 1000 adults) of Tanzania in 2008 to that in 2009?
Offer a terse response. 0.81. What is the ratio of the Borrowers(per 1000 adults) of United Kingdom in 2008 to that in 2009?
Your answer should be compact. 1.09. What is the ratio of the Borrowers(per 1000 adults) of Uruguay in 2008 to that in 2009?
Provide a succinct answer. 0.95. What is the ratio of the Borrowers(per 1000 adults) in Samoa in 2008 to that in 2010?
Your response must be concise. 1.04. What is the ratio of the Borrowers(per 1000 adults) of Tanzania in 2008 to that in 2010?
Offer a very short reply. 0.74. What is the ratio of the Borrowers(per 1000 adults) of United Kingdom in 2008 to that in 2010?
Your response must be concise. 1.16. What is the ratio of the Borrowers(per 1000 adults) of Uruguay in 2008 to that in 2010?
Your answer should be compact. 0.85. What is the ratio of the Borrowers(per 1000 adults) of Samoa in 2009 to that in 2010?
Your answer should be compact. 1. What is the ratio of the Borrowers(per 1000 adults) of Tanzania in 2009 to that in 2010?
Keep it short and to the point. 0.92. What is the ratio of the Borrowers(per 1000 adults) in United Kingdom in 2009 to that in 2010?
Offer a very short reply. 1.07. What is the ratio of the Borrowers(per 1000 adults) in Uruguay in 2009 to that in 2010?
Ensure brevity in your answer.  0.89. What is the difference between the highest and the second highest Borrowers(per 1000 adults) of Samoa?
Offer a terse response. 15.11. What is the difference between the highest and the second highest Borrowers(per 1000 adults) of Tanzania?
Ensure brevity in your answer.  2.54. What is the difference between the highest and the second highest Borrowers(per 1000 adults) in United Kingdom?
Keep it short and to the point. 0.8. What is the difference between the highest and the second highest Borrowers(per 1000 adults) in Uruguay?
Offer a terse response. 52.19. What is the difference between the highest and the lowest Borrowers(per 1000 adults) of Samoa?
Offer a very short reply. 49.94. What is the difference between the highest and the lowest Borrowers(per 1000 adults) in Tanzania?
Provide a succinct answer. 20.49. What is the difference between the highest and the lowest Borrowers(per 1000 adults) in United Kingdom?
Make the answer very short. 8.62. What is the difference between the highest and the lowest Borrowers(per 1000 adults) of Uruguay?
Ensure brevity in your answer.  256.93. 